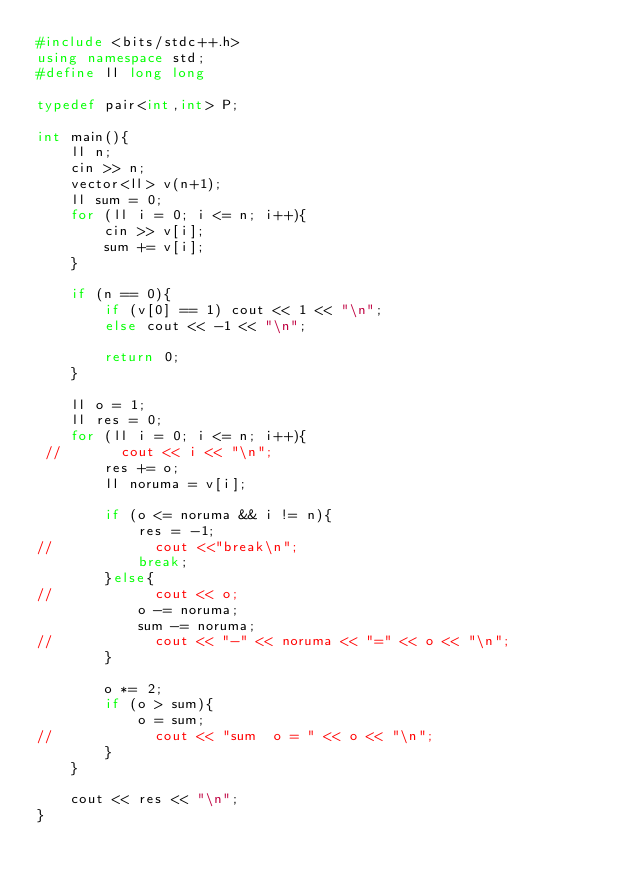<code> <loc_0><loc_0><loc_500><loc_500><_C++_>#include <bits/stdc++.h>
using namespace std;
#define ll long long

typedef pair<int,int> P;

int main(){
    ll n;
    cin >> n;
    vector<ll> v(n+1);
    ll sum = 0;
    for (ll i = 0; i <= n; i++){
        cin >> v[i];
        sum += v[i];
    }

    if (n == 0){
        if (v[0] == 1) cout << 1 << "\n";
        else cout << -1 << "\n";

        return 0;
    }

    ll o = 1;
    ll res = 0;
    for (ll i = 0; i <= n; i++){
 //       cout << i << "\n";
        res += o;
        ll noruma = v[i];

        if (o <= noruma && i != n){
            res = -1;
//            cout <<"break\n";
            break;
        }else{
//            cout << o;
            o -= noruma;
            sum -= noruma;
//            cout << "-" << noruma << "=" << o << "\n";
        }

        o *= 2;
        if (o > sum){
            o = sum;
//            cout << "sum  o = " << o << "\n";
        }
    }

    cout << res << "\n";
}</code> 